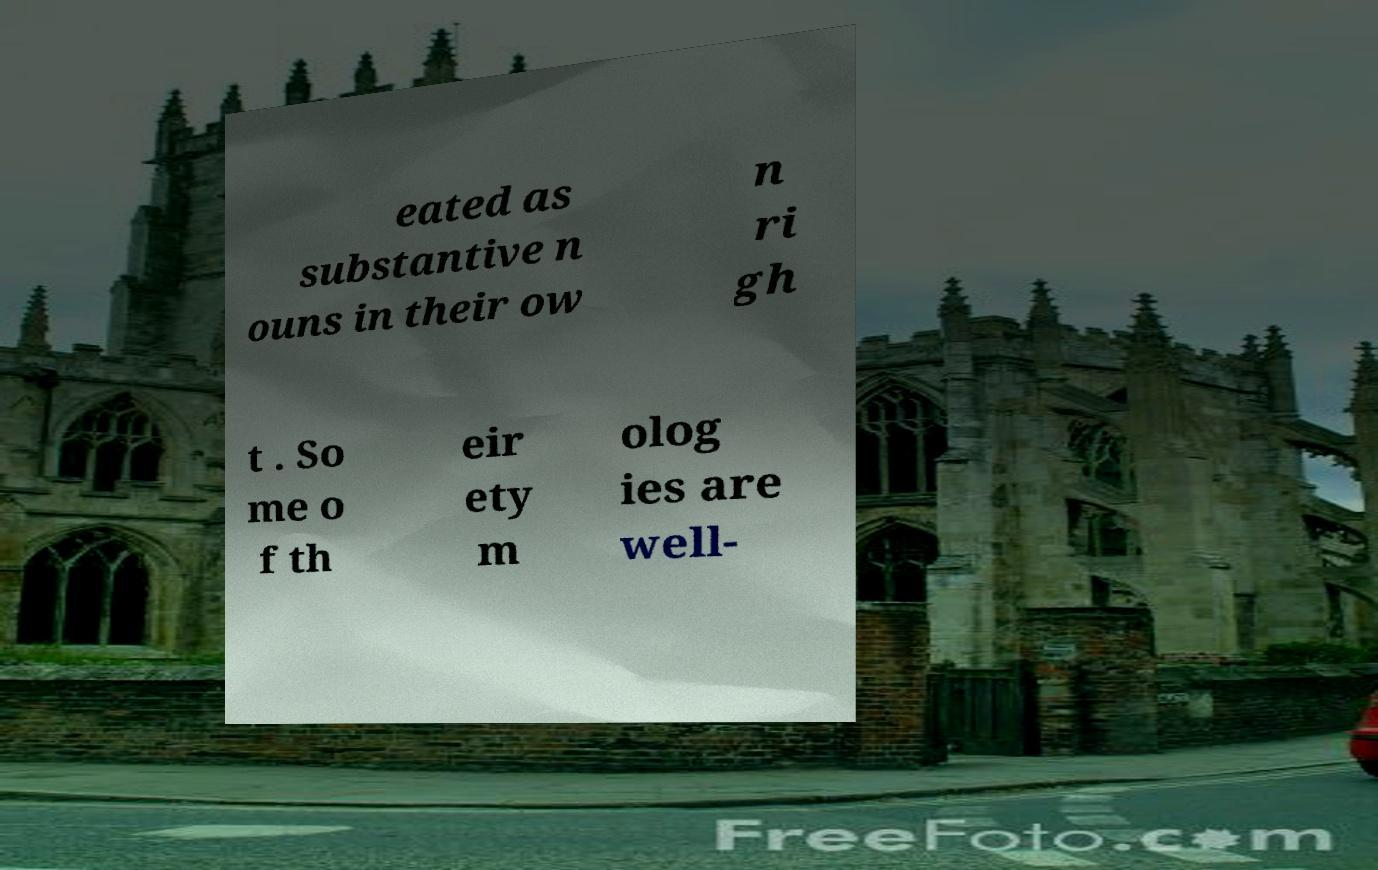Could you assist in decoding the text presented in this image and type it out clearly? eated as substantive n ouns in their ow n ri gh t . So me o f th eir ety m olog ies are well- 